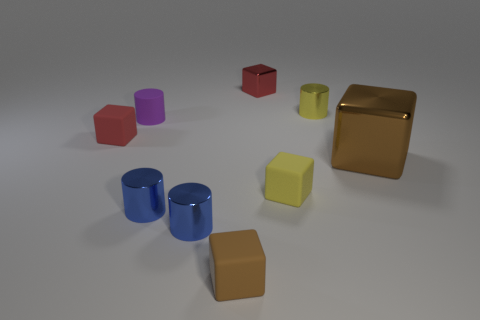Does the small red block that is in front of the red metal object have the same material as the yellow thing that is behind the purple cylinder?
Keep it short and to the point. No. What number of yellow objects are cylinders or matte cylinders?
Provide a short and direct response. 1. How big is the matte cylinder?
Offer a terse response. Small. Are there more large brown shiny cubes in front of the tiny red shiny thing than small blue shiny cylinders?
Your answer should be very brief. No. There is a small red metallic object; what number of red objects are left of it?
Your response must be concise. 1. Is there a purple matte object of the same size as the red metallic object?
Provide a short and direct response. Yes. There is a big thing that is the same shape as the small brown object; what is its color?
Offer a very short reply. Brown. Do the metallic cylinder that is behind the rubber cylinder and the yellow object in front of the tiny purple cylinder have the same size?
Make the answer very short. Yes. Are there any other large things that have the same shape as the large thing?
Offer a very short reply. No. Are there an equal number of small brown matte blocks behind the tiny brown object and small blue things?
Offer a terse response. No. 